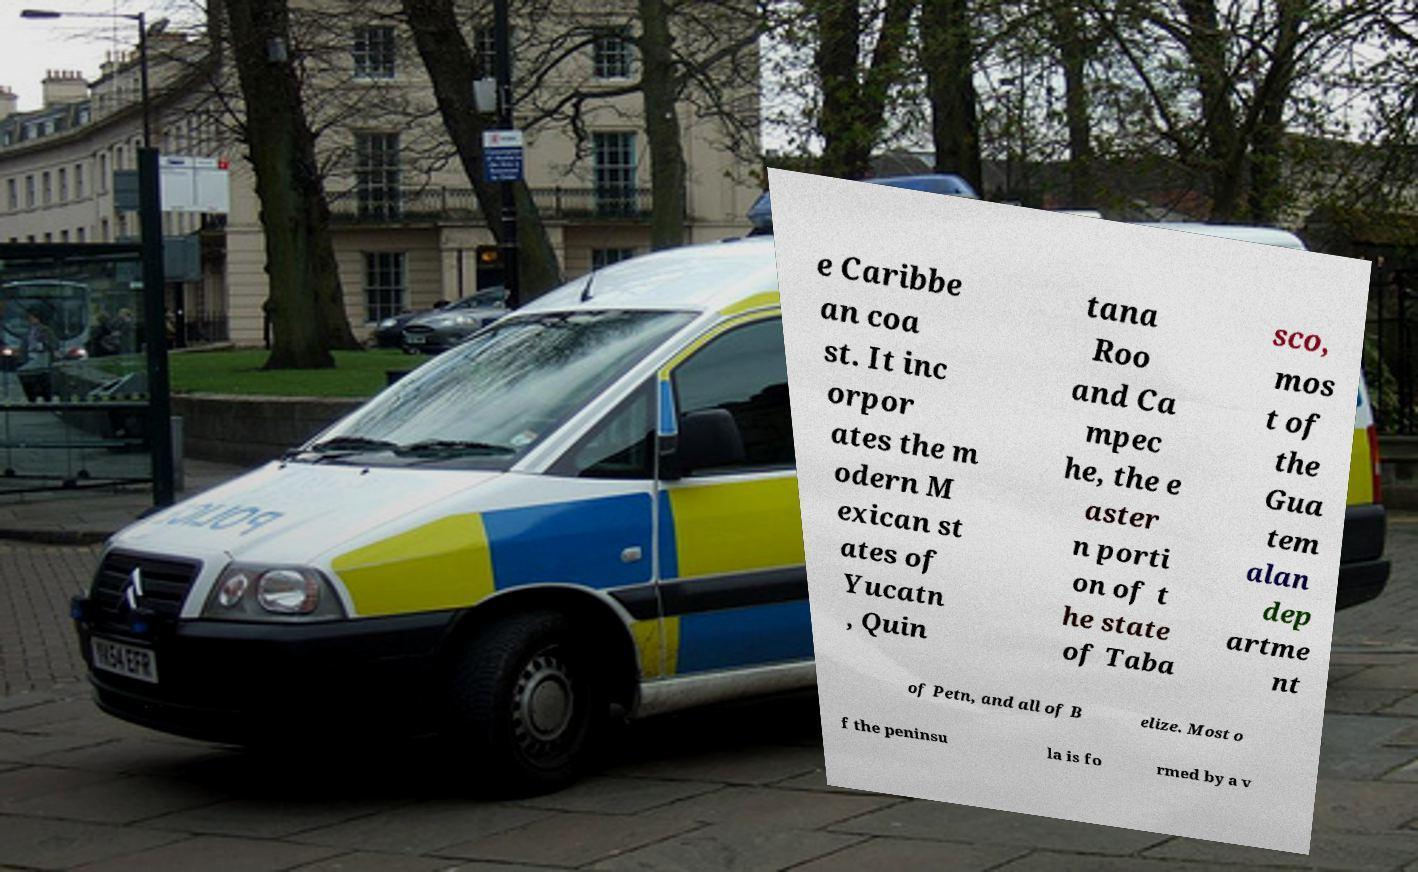Can you accurately transcribe the text from the provided image for me? e Caribbe an coa st. It inc orpor ates the m odern M exican st ates of Yucatn , Quin tana Roo and Ca mpec he, the e aster n porti on of t he state of Taba sco, mos t of the Gua tem alan dep artme nt of Petn, and all of B elize. Most o f the peninsu la is fo rmed by a v 